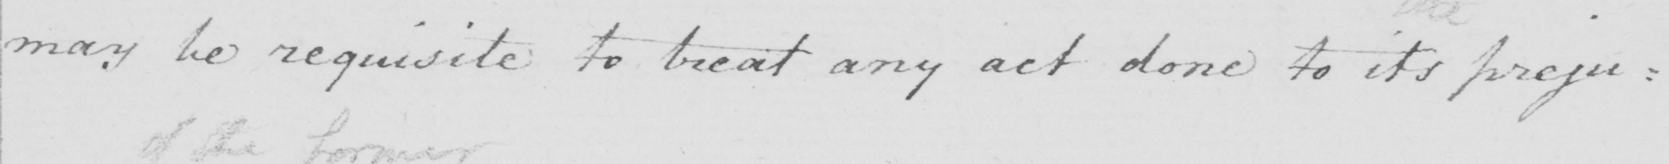Can you tell me what this handwritten text says? may be requisite to treat any act done to its preju : 